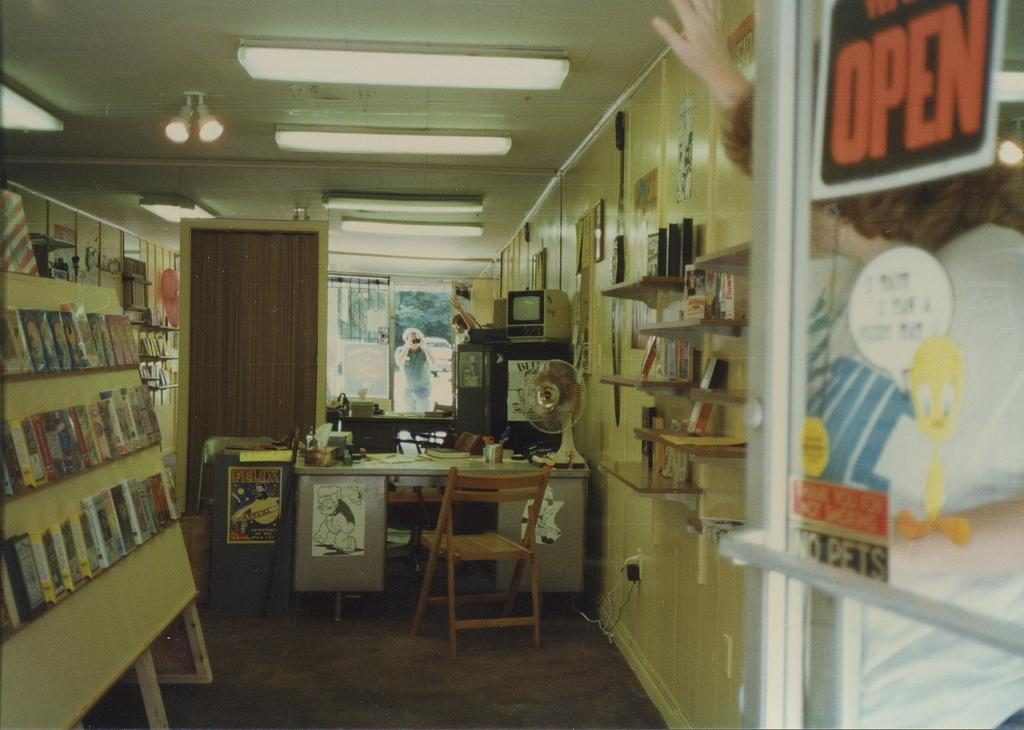<image>
Create a compact narrative representing the image presented. Movie store with an open sign in black and orange. 